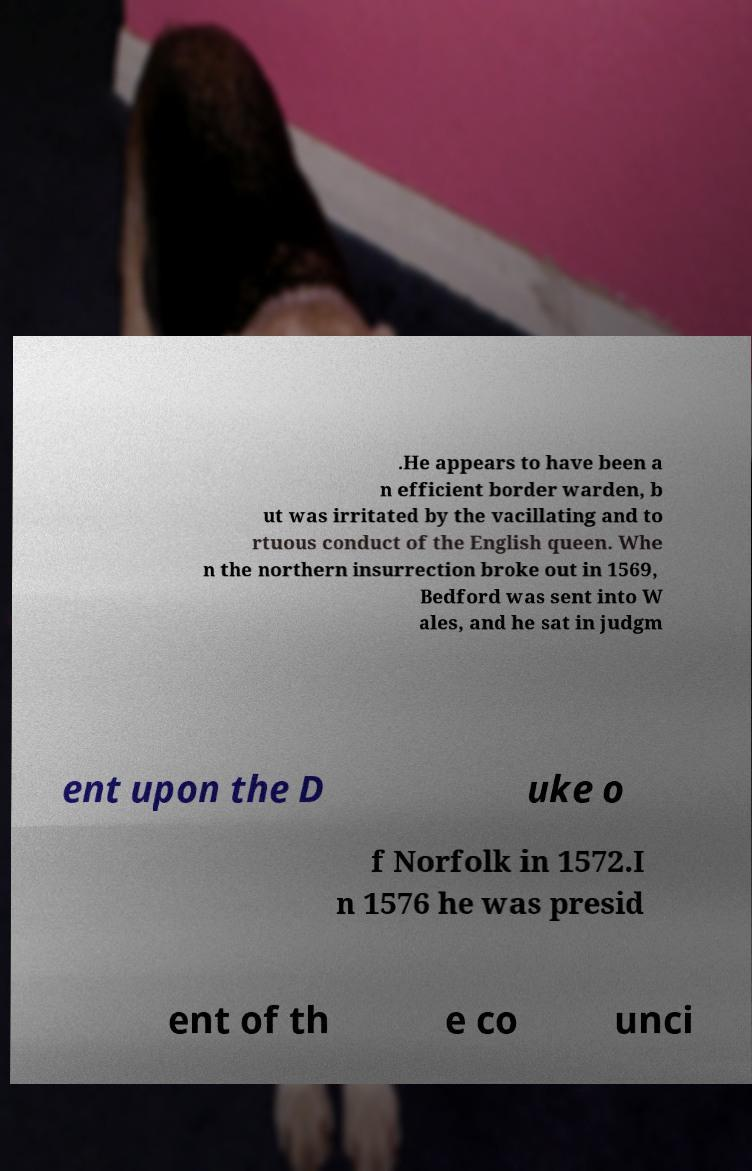For documentation purposes, I need the text within this image transcribed. Could you provide that? .He appears to have been a n efficient border warden, b ut was irritated by the vacillating and to rtuous conduct of the English queen. Whe n the northern insurrection broke out in 1569, Bedford was sent into W ales, and he sat in judgm ent upon the D uke o f Norfolk in 1572.I n 1576 he was presid ent of th e co unci 